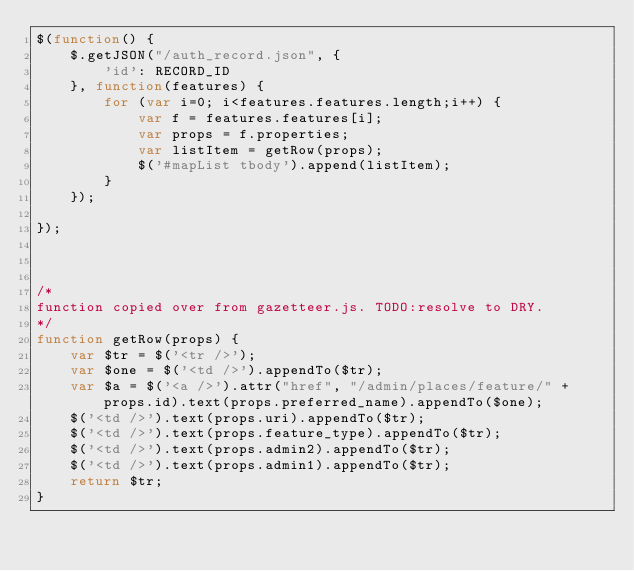Convert code to text. <code><loc_0><loc_0><loc_500><loc_500><_JavaScript_>$(function() {
    $.getJSON("/auth_record.json", {
        'id': RECORD_ID
    }, function(features) {
        for (var i=0; i<features.features.length;i++) {
            var f = features.features[i];
            var props = f.properties;
            var listItem = getRow(props);
            $('#mapList tbody').append(listItem);
        }                  
    });

});



/*
function copied over from gazetteer.js. TODO:resolve to DRY.
*/
function getRow(props) {
    var $tr = $('<tr />');
    var $one = $('<td />').appendTo($tr);
    var $a = $('<a />').attr("href", "/admin/places/feature/" + props.id).text(props.preferred_name).appendTo($one);
    $('<td />').text(props.uri).appendTo($tr);
    $('<td />').text(props.feature_type).appendTo($tr);
    $('<td />').text(props.admin2).appendTo($tr);
    $('<td />').text(props.admin1).appendTo($tr);
    return $tr;     
}

</code> 